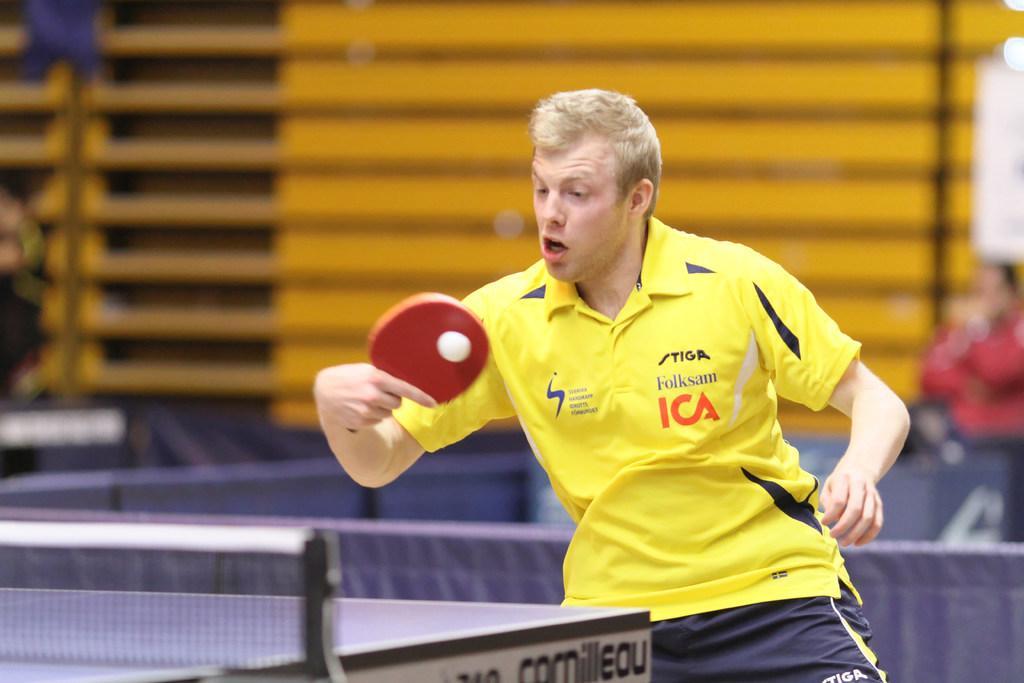In one or two sentences, can you explain what this image depicts? This person standing and playing table tennis and holding bat. This is table tennis. On the background we can see persons. 